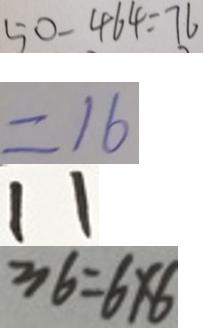<formula> <loc_0><loc_0><loc_500><loc_500>5 0 - 4 6 4 = 7 6 
 = 1 6 
 1 1 
 3 6 = 6 \times 6</formula> 